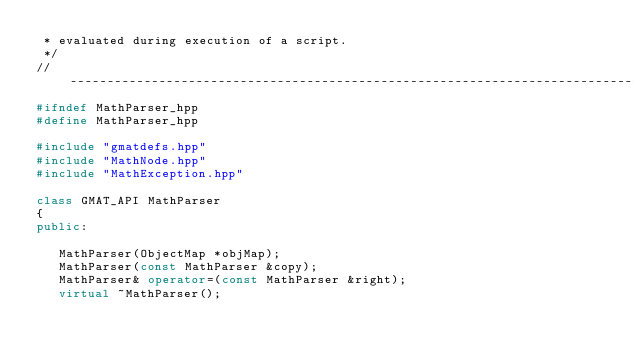Convert code to text. <code><loc_0><loc_0><loc_500><loc_500><_C++_> * evaluated during execution of a script.
 */
//------------------------------------------------------------------------------
#ifndef MathParser_hpp
#define MathParser_hpp

#include "gmatdefs.hpp"
#include "MathNode.hpp"
#include "MathException.hpp"

class GMAT_API MathParser
{
public:
   
   MathParser(ObjectMap *objMap);
   MathParser(const MathParser &copy);
   MathParser& operator=(const MathParser &right);
   virtual ~MathParser();
   </code> 